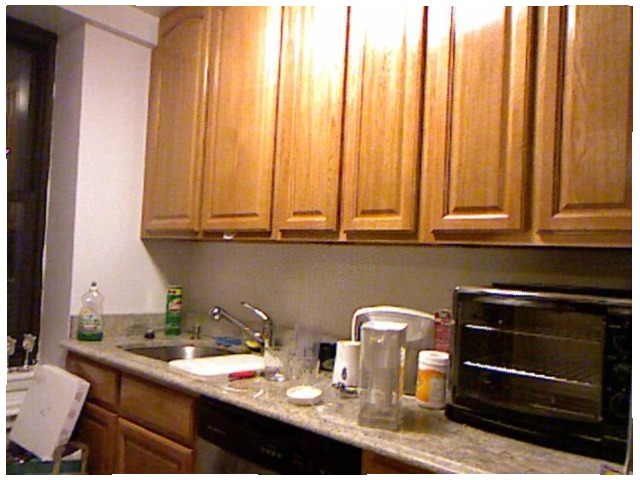<image>
Can you confirm if the cleaner is on the counter? Yes. Looking at the image, I can see the cleaner is positioned on top of the counter, with the counter providing support. Is there a water in the faucet? No. The water is not contained within the faucet. These objects have a different spatial relationship. 